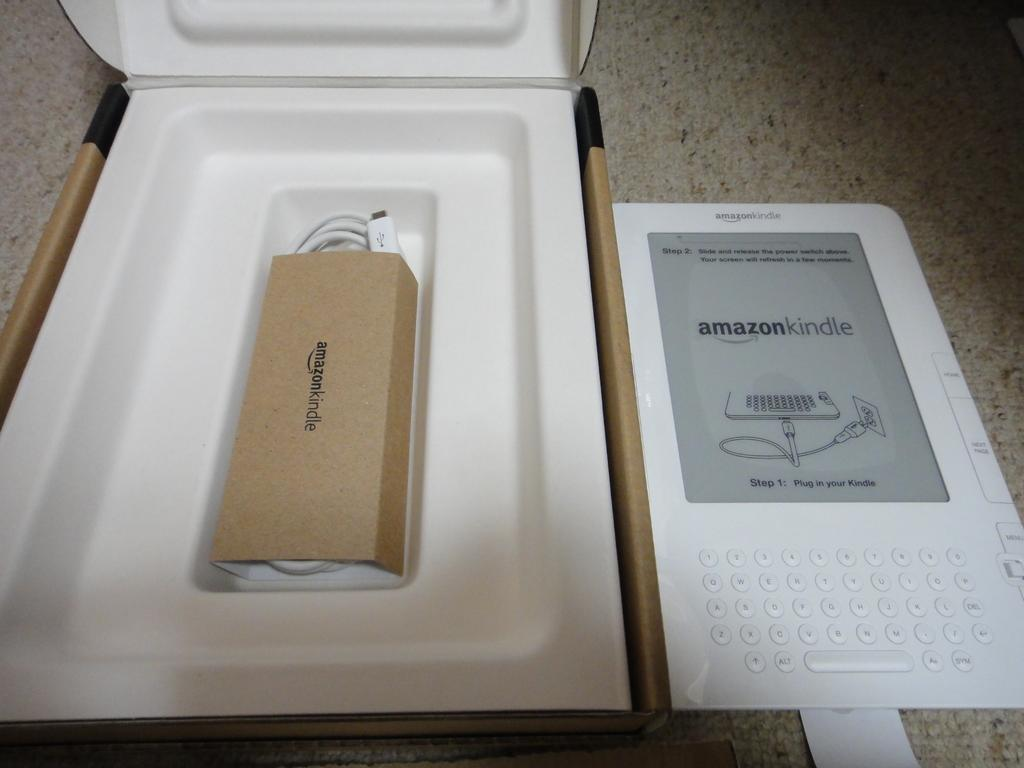<image>
Present a compact description of the photo's key features. A white Amazon Kindle sitting next to open packaging. 